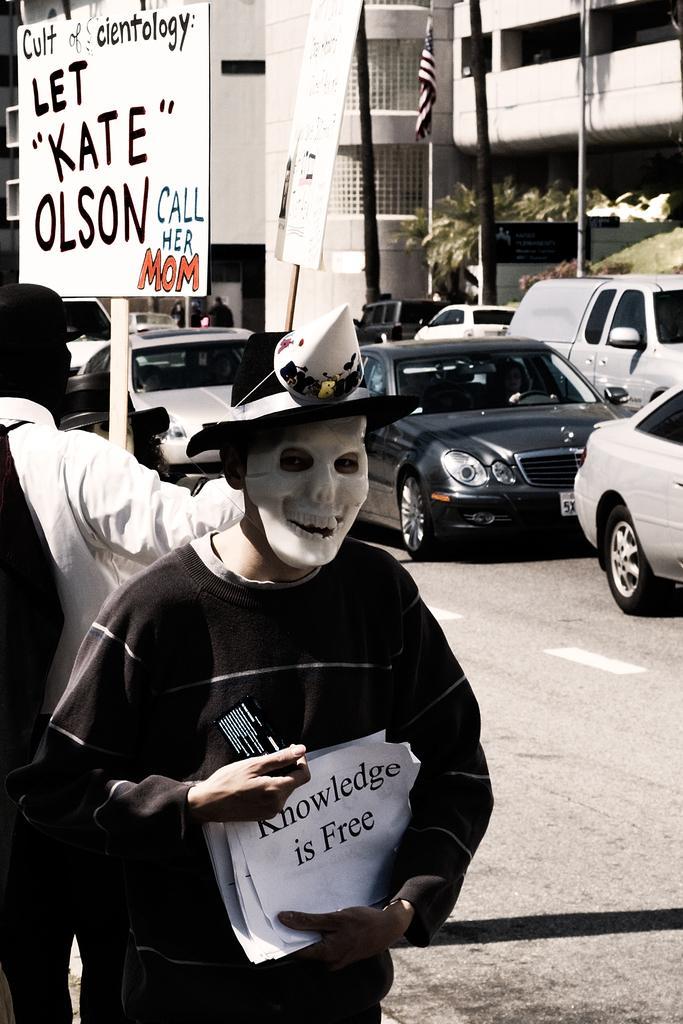Can you describe this image briefly? In this image, we can see vehicles on the road and in the background, there are buildings, poles and we can see a flag. In the front, we can see a person wearing costume and holding some papers and there is an another person holding a board. 